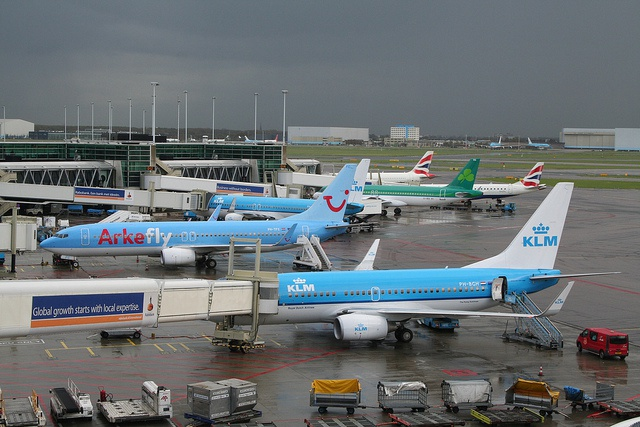Describe the objects in this image and their specific colors. I can see airplane in gray, lightgray, lightblue, and darkgray tones, airplane in gray, lightblue, and darkgray tones, airplane in gray, teal, and darkgray tones, airplane in gray, lightgray, lightblue, and darkgray tones, and truck in gray, darkgray, black, and purple tones in this image. 